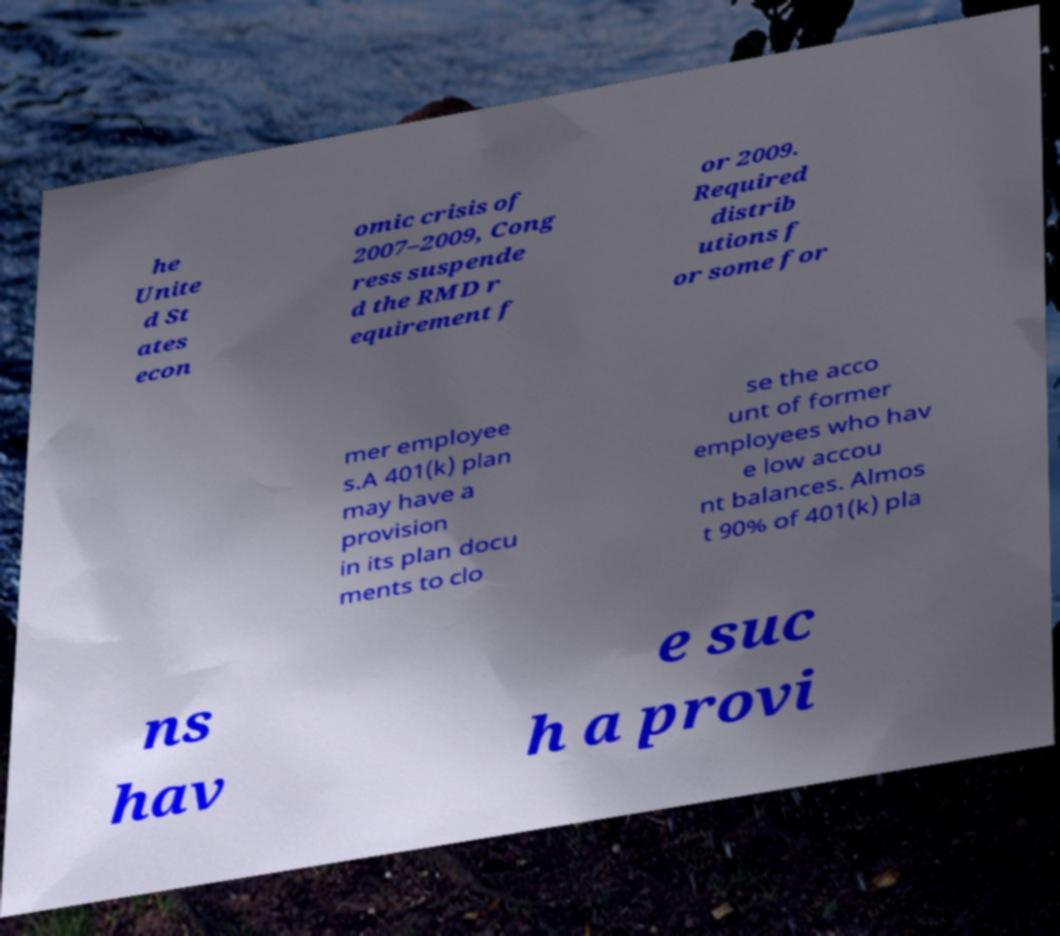Could you extract and type out the text from this image? he Unite d St ates econ omic crisis of 2007–2009, Cong ress suspende d the RMD r equirement f or 2009. Required distrib utions f or some for mer employee s.A 401(k) plan may have a provision in its plan docu ments to clo se the acco unt of former employees who hav e low accou nt balances. Almos t 90% of 401(k) pla ns hav e suc h a provi 